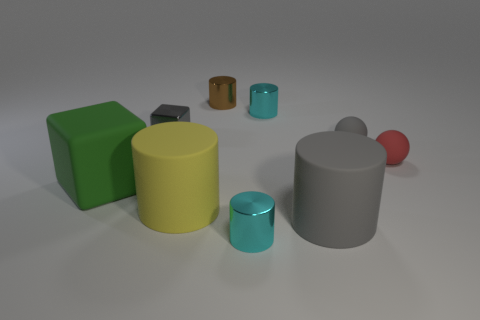Are there any large matte cylinders?
Your response must be concise. Yes. Are there any things behind the small gray ball?
Offer a terse response. Yes. What material is the brown thing that is the same shape as the yellow thing?
Offer a very short reply. Metal. Is there any other thing that has the same material as the large green cube?
Offer a very short reply. Yes. What number of other objects are the same shape as the large green thing?
Keep it short and to the point. 1. How many cyan metallic things are in front of the gray matte object that is in front of the tiny ball left of the tiny red matte sphere?
Your answer should be very brief. 1. How many yellow objects are the same shape as the red thing?
Provide a short and direct response. 0. There is a rubber cylinder that is on the left side of the small brown thing; does it have the same color as the big block?
Your response must be concise. No. What is the shape of the cyan object that is behind the tiny matte thing that is to the right of the gray ball that is on the right side of the small brown shiny thing?
Your response must be concise. Cylinder. Does the gray cube have the same size as the cyan shiny object that is behind the tiny gray rubber thing?
Give a very brief answer. Yes. 